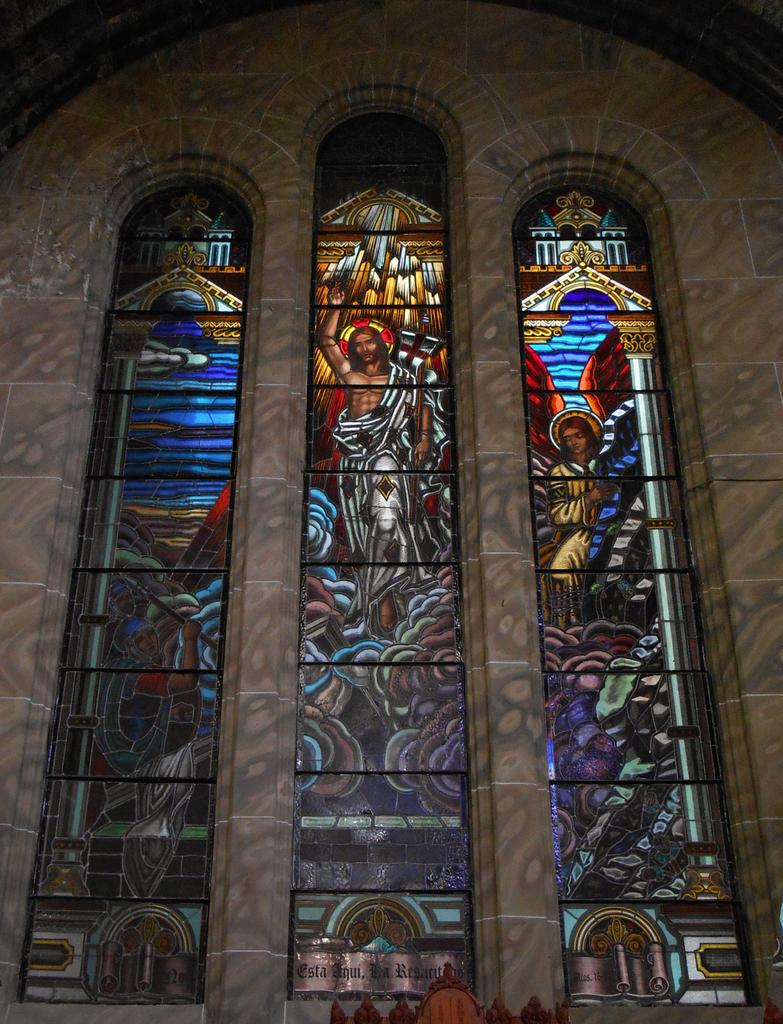What type of structure is visible in the image? There is a wall in the image. What features can be seen on the wall? The wall has windows and a painting of a person. What architectural elements are present in the middle of the image? There are pillars in the middle of the image. Can you describe the shape of the lake in the image? There is no lake present in the image; it features a wall with windows, a painting, and pillars. What type of mine is depicted in the painting on the wall? The painting on the wall does not depict a mine; it is a painting of a person. 